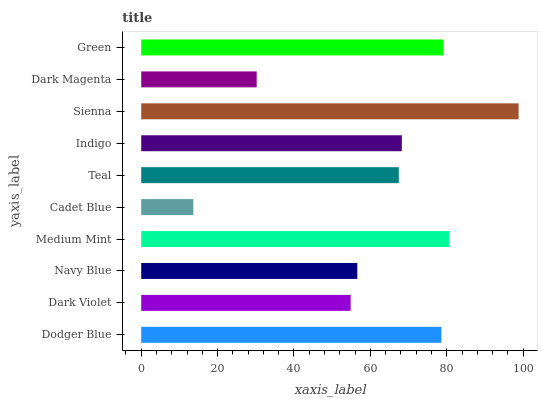Is Cadet Blue the minimum?
Answer yes or no. Yes. Is Sienna the maximum?
Answer yes or no. Yes. Is Dark Violet the minimum?
Answer yes or no. No. Is Dark Violet the maximum?
Answer yes or no. No. Is Dodger Blue greater than Dark Violet?
Answer yes or no. Yes. Is Dark Violet less than Dodger Blue?
Answer yes or no. Yes. Is Dark Violet greater than Dodger Blue?
Answer yes or no. No. Is Dodger Blue less than Dark Violet?
Answer yes or no. No. Is Indigo the high median?
Answer yes or no. Yes. Is Teal the low median?
Answer yes or no. Yes. Is Cadet Blue the high median?
Answer yes or no. No. Is Dark Magenta the low median?
Answer yes or no. No. 